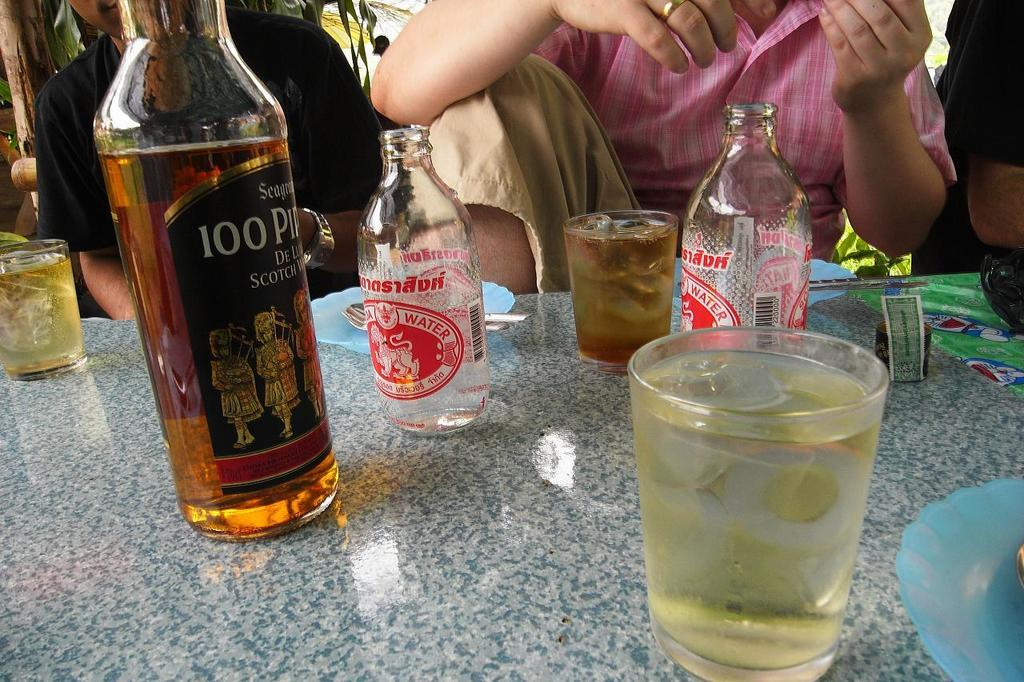<image>
Write a terse but informative summary of the picture. A bottle of alcohol has a large number 100 on it and sits on a table. 